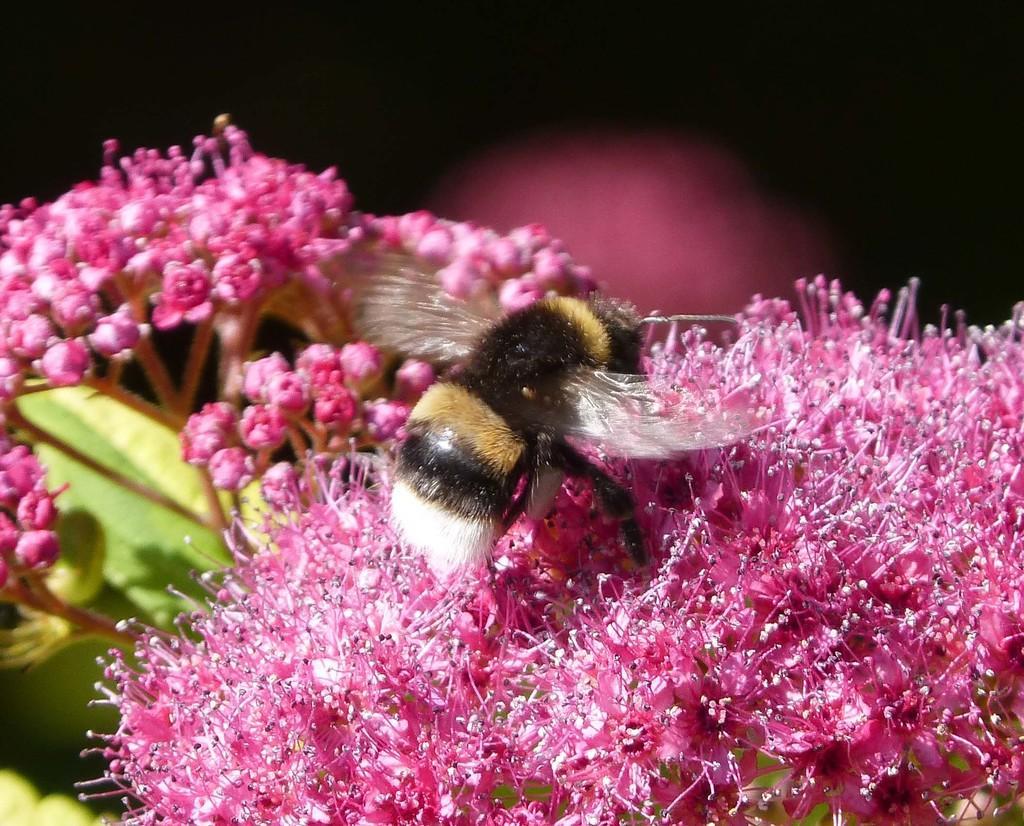How would you summarize this image in a sentence or two? In this picture there is an insect on pink color flowers. 